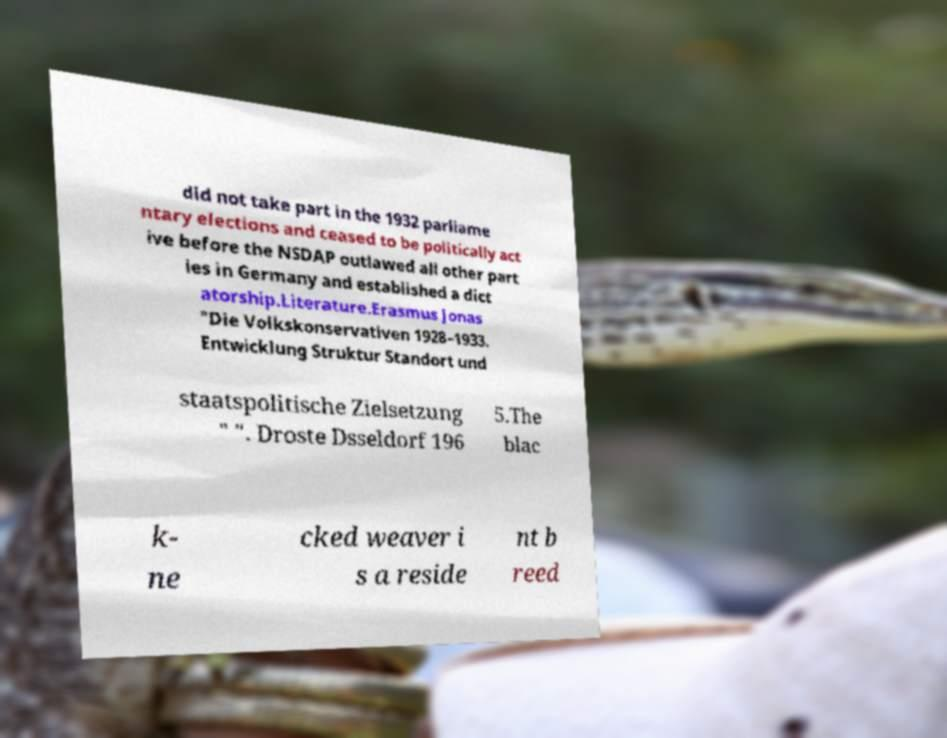For documentation purposes, I need the text within this image transcribed. Could you provide that? did not take part in the 1932 parliame ntary elections and ceased to be politically act ive before the NSDAP outlawed all other part ies in Germany and established a dict atorship.Literature.Erasmus Jonas "Die Volkskonservativen 1928–1933. Entwicklung Struktur Standort und staatspolitische Zielsetzung " ". Droste Dsseldorf 196 5.The blac k- ne cked weaver i s a reside nt b reed 